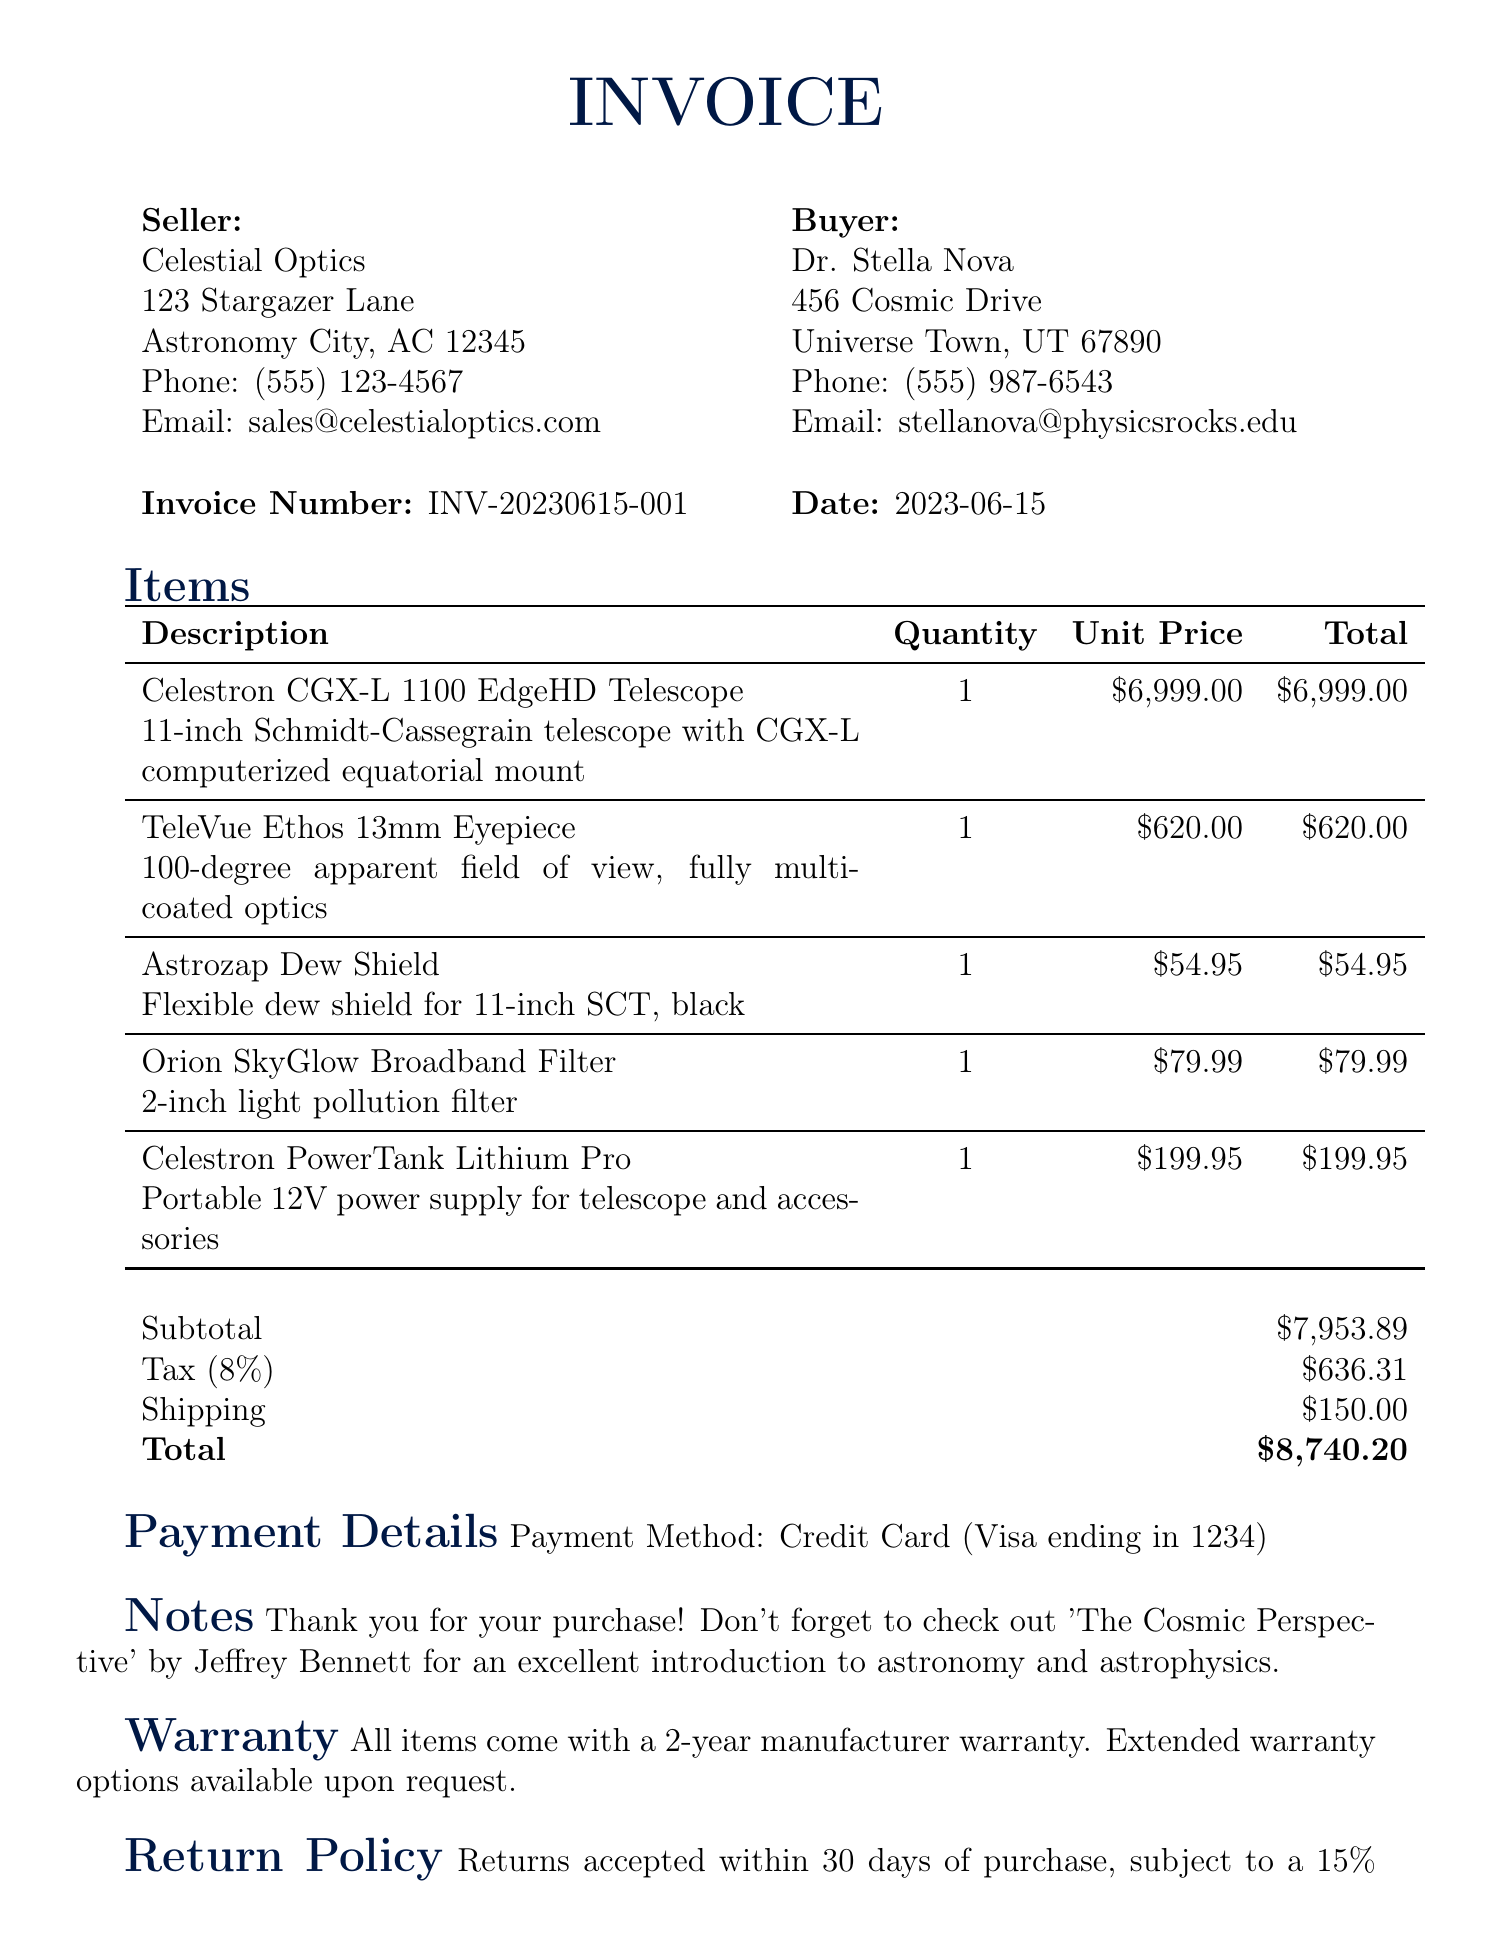what is the invoice number? The invoice number is found in a specific section of the document detailing it uniquely, which is INV-20230615-001.
Answer: INV-20230615-001 who is the seller? The seller's name is provided at the beginning of the document, identifying the company selling the items as Celestial Optics.
Answer: Celestial Optics what is the total amount due? The total amount is calculated based on the subtotal, tax, and shipping costs, which adds up to a final amount of $8740.20.
Answer: $8740.20 how many items were purchased? The number of unique items is indicated in the items section, where different products are listed, totaling five items.
Answer: 5 what is the shipping cost? The shipping cost is explicitly listed in a separate section of the invoice, which indicates it as $150.00.
Answer: $150.00 what is the tax rate applied? The tax rate is stated in the financial summary of the invoice, which is 8%.
Answer: 8% who is the buyer? The buyer's name is located in the buyer section of the document, identifying them as Dr. Stella Nova.
Answer: Dr. Stella Nova what is the warranty period for the items? The warranty is mentioned in a dedicated section, specifying that it lasts for two years for all items.
Answer: 2 years what payment method was used? The payment method is clearly described in the payment details section, listing it as a credit card.
Answer: Credit Card (Visa ending in 1234) what is the return policy duration? The return policy duration is specified in its section, indicating that returns are accepted within 30 days of purchase.
Answer: 30 days 